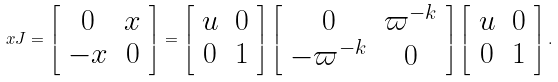<formula> <loc_0><loc_0><loc_500><loc_500>x J = \left [ \begin{array} { c c } 0 & x \\ - x & 0 \end{array} \right ] = \left [ \begin{array} { c c } u & 0 \\ 0 & 1 \end{array} \right ] \left [ \begin{array} { c c } 0 & \varpi ^ { - k } \\ - \varpi ^ { - k } & 0 \end{array} \right ] \left [ \begin{array} { c c } u & 0 \\ 0 & 1 \end{array} \right ] .</formula> 